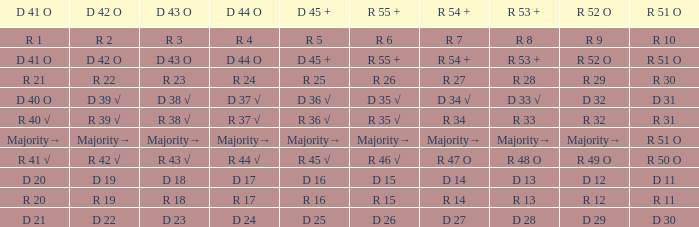What is the value of D 43 O that has a corresponding R 53 + value of r 8? R 3. 